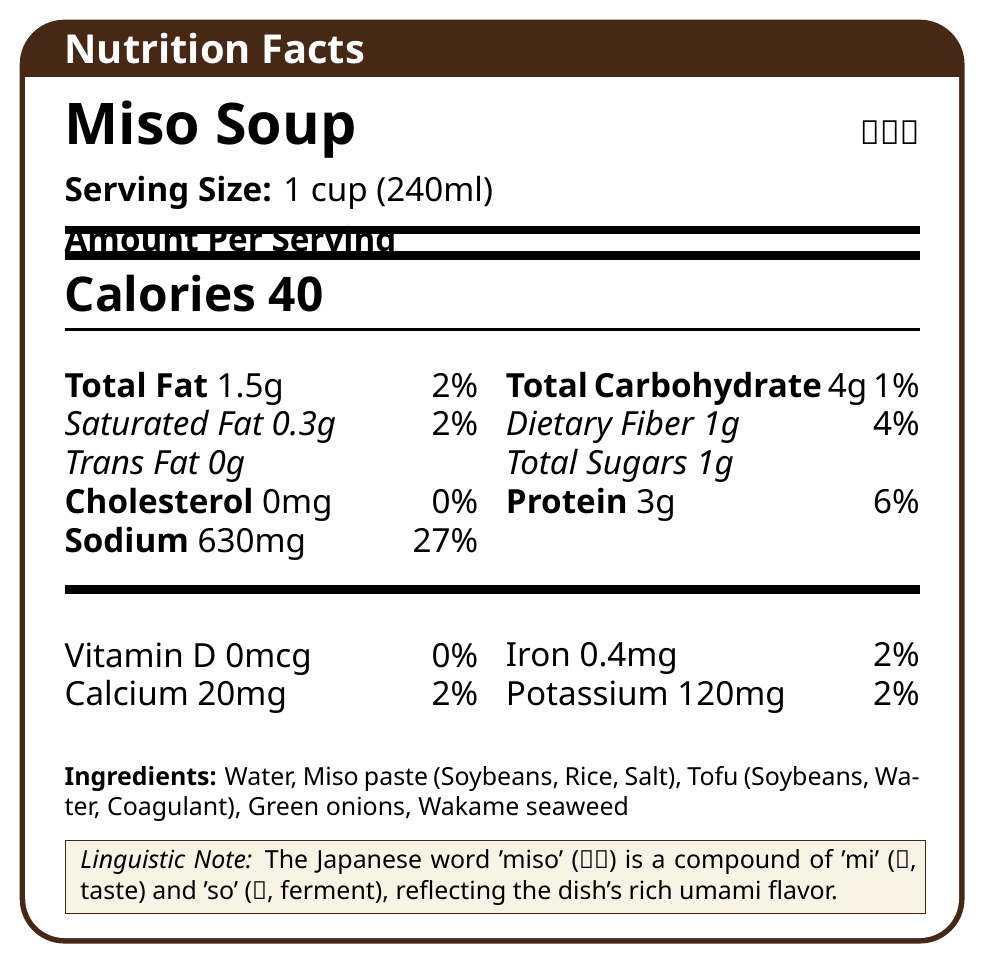What is the serving size of the Miso Soup in English? The Nutrition Facts document states the serving size, listed as "1 cup (240ml)" in English.
Answer: 1 cup (240ml) What is the amount of sodium per serving? The document shows that the amount of sodium per serving is 630mg.
Answer: 630mg How many grams of total carbohydrates are there in one serving? The total carbohydrate content per serving is shown as 4g in the document.
Answer: 4g What is the percentage of the daily value for dietary fiber? According to the document, the dietary fiber in one serving makes up 4% of the daily value.
Answer: 4% List all the ingredients included in the Miso Soup. The document provides a list of ingredients: Water, Miso paste (Soybeans, Rice, Salt), Tofu (Soybeans, Water, Coagulant), Green onions, and Wakame seaweed.
Answer: Water, Miso paste (Soybeans, Rice, Salt), Tofu (Soybeans, Water, Coagulant), Green onions, Wakame seaweed What is the calorie content per serving? The calorie content is listed as 40 Calories per serving in the document.
Answer: 40 Calories In Japanese, how is "Saturated Fat" labeled? The document shows the Japanese label for Saturated Fat as "飽和脂肪酸".
Answer: 飽和脂肪酸 Which nutrient has a value of 0mcg per serving? A. Cholesterol B. Trans Fat C. Vitamin D D. Sodium The document shows that Vitamin D has a value of 0mcg per serving.
Answer: C. Vitamin D What percentage of daily value for sodium does one serving contain? A. 10% B. 27% C. 40% The document states that the sodium content in one serving is 27% of the daily value.
Answer: B. 27% Is there any Trans Fat in the Miso Soup? The document lists Trans Fat as 0g per serving, indicating that there is no Trans Fat.
Answer: No How would you summarize the nutritional information provided in the document? The document gives a comprehensive overview of the nutritional content, ingredient list, and a linguistic note, summarizing the health aspects and cultural background of Miso Soup.
Answer: The document provides a detailed nutritional breakdown for a serving size of 1 cup (240ml) of Miso Soup. It includes calorie count, macronutrients such as fats, carbohydrates, protein, vitamins, and minerals. Moreover, it lists ingredients and provides a linguistic note about the Japanese word 'miso'. What is the exact percentage of the daily value for calcium per serving? The document specifies that one serving of Miso Soup provides 2% of the daily value for calcium.
Answer: 2% What ingredient in the Miso Soup provides the primary source of protein? The document lists Tofu (Soybeans, Water, Coagulant) as one of the ingredients, which is a common source of protein.
Answer: Tofu (Soybeans, Water, Coagulant) How much iron is there per serving? The document lists the iron content as 0.4mg per serving.
Answer: 0.4mg What is the value of potassium per serving? The document states that there are 120mg of potassium per serving.
Answer: 120 mg From which language is the word 'miso' derived, and what does it mean? The document contains a linguistic note explaining that the word 'miso' is derived from Japanese and is a compound of 'mi' (taste) and 'so' (ferment).
Answer: Japanese; 'miso' is a compound of 'mi' (taste) and 'so' (ferment) Is the percentage of daily value for cholesterol more than that for saturated fat? The percentage of daily value for cholesterol is 0%, whereas for saturated fat it is 2%, as shown in the document.
Answer: No What is the total fiber content per serving, and what percentage of the daily value does it represent? The total dietary fiber content per serving is 1g, which represents 4% of the daily value, as per the document.
Answer: 1g, 4% 